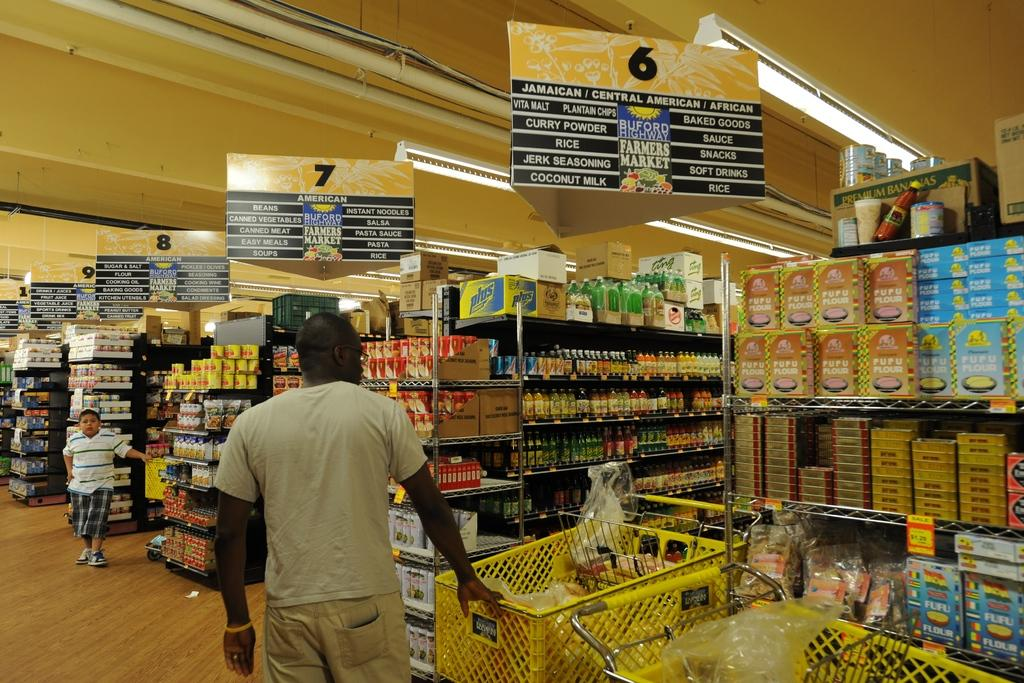<image>
Describe the image concisely. A man stands in front of aisle 6 in a supermarket. 